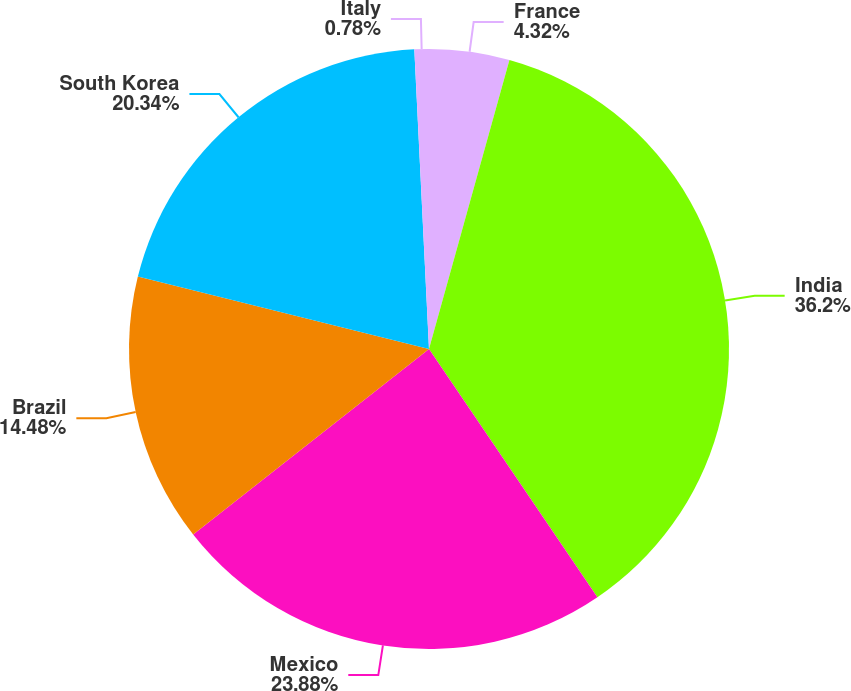<chart> <loc_0><loc_0><loc_500><loc_500><pie_chart><fcel>France<fcel>India<fcel>Mexico<fcel>Brazil<fcel>South Korea<fcel>Italy<nl><fcel>4.32%<fcel>36.19%<fcel>23.88%<fcel>14.48%<fcel>20.34%<fcel>0.78%<nl></chart> 